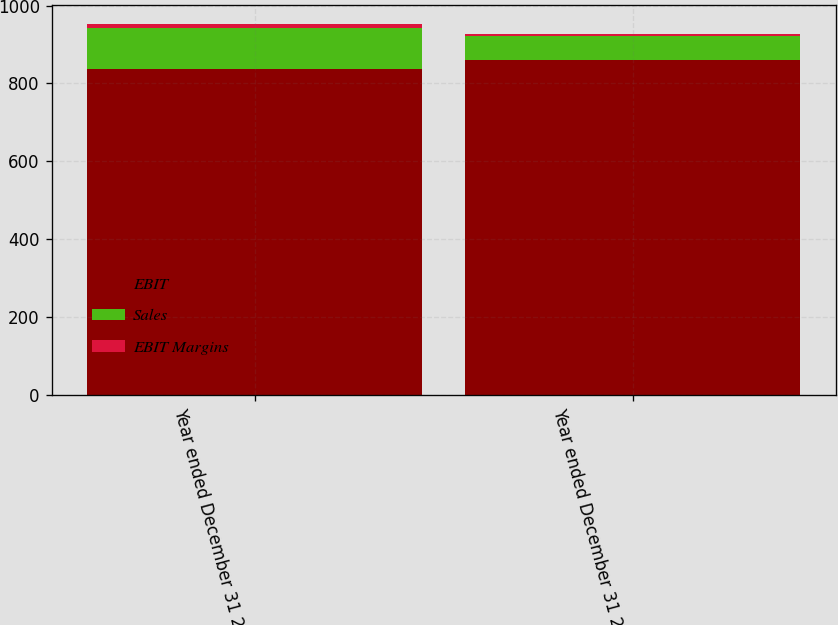Convert chart. <chart><loc_0><loc_0><loc_500><loc_500><stacked_bar_chart><ecel><fcel>Year ended December 31 2007<fcel>Year ended December 31 2006<nl><fcel>EBIT<fcel>837<fcel>861<nl><fcel>Sales<fcel>104<fcel>60<nl><fcel>EBIT Margins<fcel>12.4<fcel>7<nl></chart> 